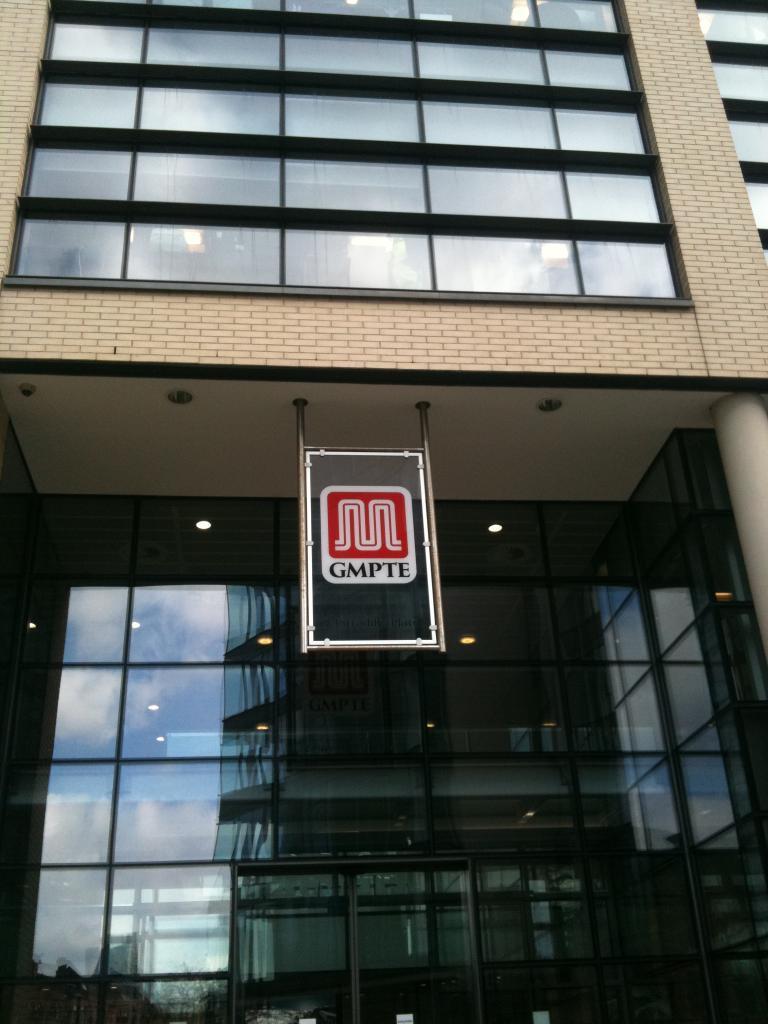Describe this image in one or two sentences. In this picture there is a building and there is a board and there is a text on the board. There is a reflection of sky and clouds and trees on the mirrors. There are lights inside the building. 